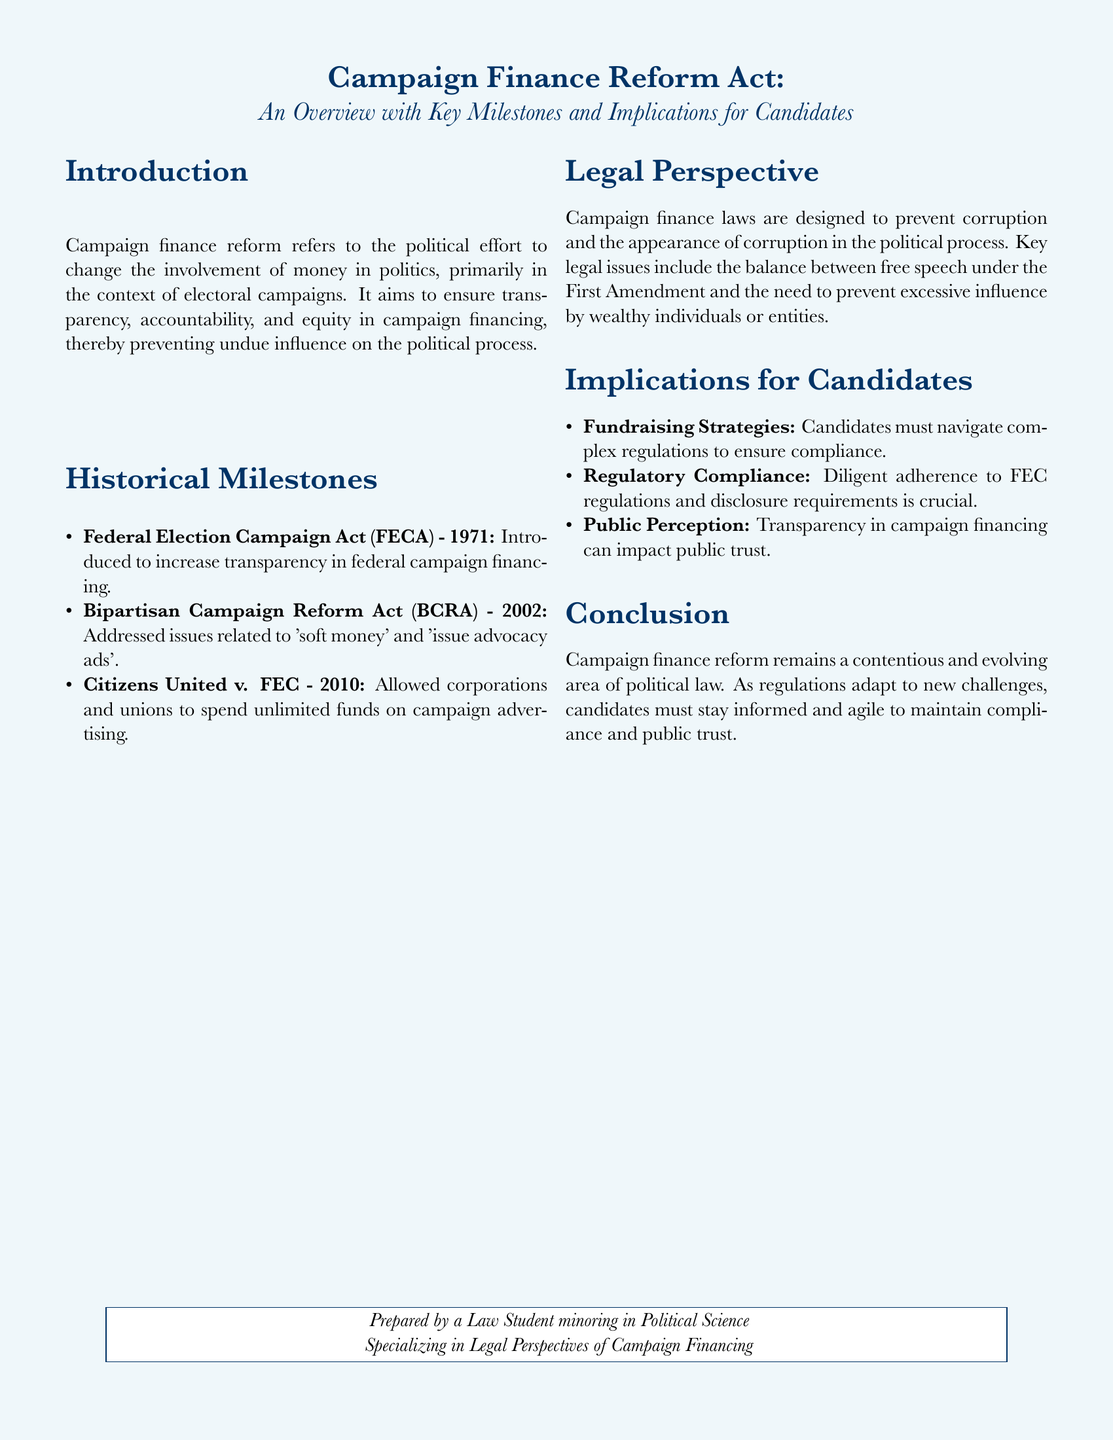What is the primary purpose of campaign finance reform? The document states that it aims to ensure transparency, accountability, and equity in campaign financing.
Answer: Transparency, accountability, and equity What year was the Federal Election Campaign Act introduced? The document lists the year as part of the historical milestones.
Answer: 1971 What did the Bipartisan Campaign Reform Act address? According to the document, it addressed issues related to 'soft money' and 'issue advocacy ads'.
Answer: 'Soft money' and 'issue advocacy ads' What key legal case allowed corporations to spend unlimited funds on campaign advertising? The document mentions a specific legal case that had this implication.
Answer: Citizens United v. FEC What is a major implication for candidates concerning fundraising strategies? The document mentions that candidates must navigate complex regulations for compliance.
Answer: Navigate complex regulations What does the document suggest is crucial for regulatory compliance? The document emphasizes the importance of adherence to FEC regulations and disclosure requirements.
Answer: Adherence to FEC regulations Which amendment is associated with the balance of free speech and preventing influence in campaign finance? The document indicates that this balance relates to the First Amendment.
Answer: First Amendment What type of perspective does the document provide on campaign finance? The document specifically points out a legal perspective of campaign financing.
Answer: Legal perspective Who prepared the document according to the conclusion? The conclusion notes that a specific type of individual prepared the document.
Answer: Law Student minoring in Political Science 